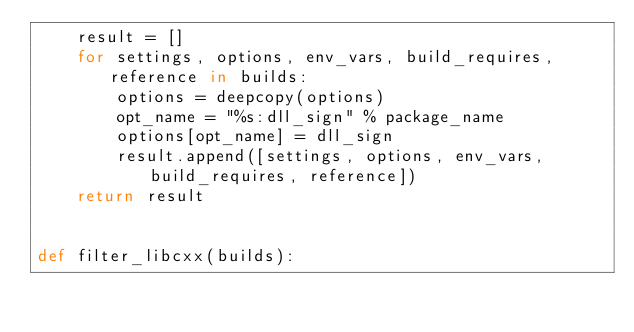Convert code to text. <code><loc_0><loc_0><loc_500><loc_500><_Python_>    result = []
    for settings, options, env_vars, build_requires, reference in builds:
        options = deepcopy(options)
        opt_name = "%s:dll_sign" % package_name
        options[opt_name] = dll_sign
        result.append([settings, options, env_vars, build_requires, reference])
    return result


def filter_libcxx(builds):</code> 